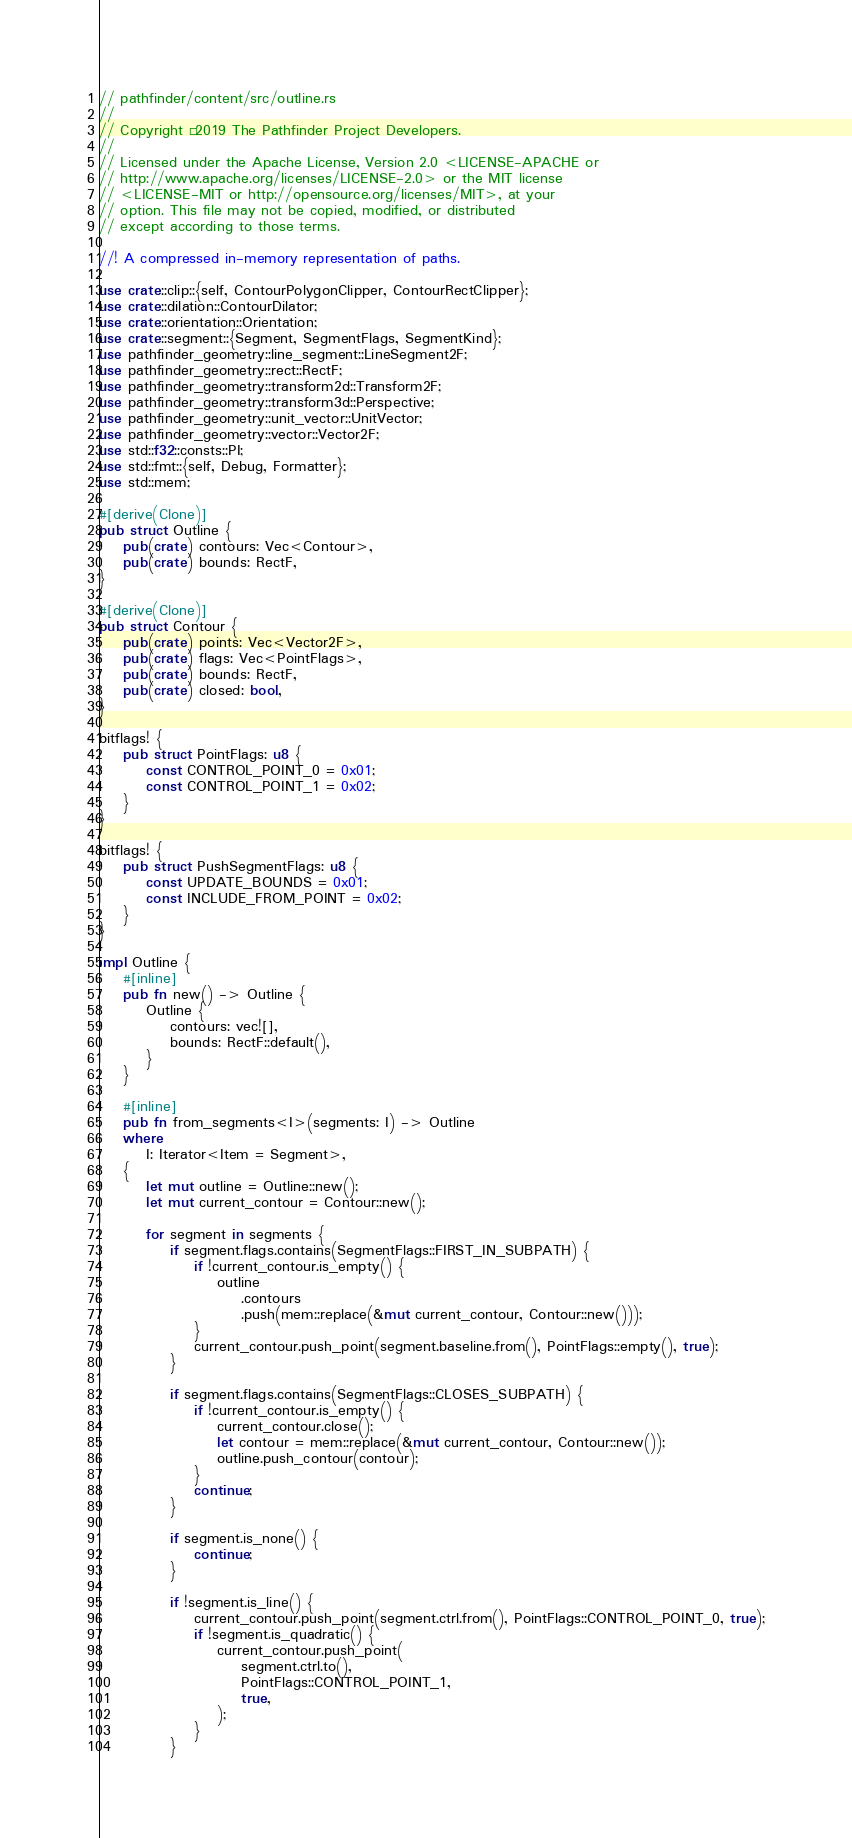Convert code to text. <code><loc_0><loc_0><loc_500><loc_500><_Rust_>// pathfinder/content/src/outline.rs
//
// Copyright © 2019 The Pathfinder Project Developers.
//
// Licensed under the Apache License, Version 2.0 <LICENSE-APACHE or
// http://www.apache.org/licenses/LICENSE-2.0> or the MIT license
// <LICENSE-MIT or http://opensource.org/licenses/MIT>, at your
// option. This file may not be copied, modified, or distributed
// except according to those terms.

//! A compressed in-memory representation of paths.

use crate::clip::{self, ContourPolygonClipper, ContourRectClipper};
use crate::dilation::ContourDilator;
use crate::orientation::Orientation;
use crate::segment::{Segment, SegmentFlags, SegmentKind};
use pathfinder_geometry::line_segment::LineSegment2F;
use pathfinder_geometry::rect::RectF;
use pathfinder_geometry::transform2d::Transform2F;
use pathfinder_geometry::transform3d::Perspective;
use pathfinder_geometry::unit_vector::UnitVector;
use pathfinder_geometry::vector::Vector2F;
use std::f32::consts::PI;
use std::fmt::{self, Debug, Formatter};
use std::mem;

#[derive(Clone)]
pub struct Outline {
    pub(crate) contours: Vec<Contour>,
    pub(crate) bounds: RectF,
}

#[derive(Clone)]
pub struct Contour {
    pub(crate) points: Vec<Vector2F>,
    pub(crate) flags: Vec<PointFlags>,
    pub(crate) bounds: RectF,
    pub(crate) closed: bool,
}

bitflags! {
    pub struct PointFlags: u8 {
        const CONTROL_POINT_0 = 0x01;
        const CONTROL_POINT_1 = 0x02;
    }
}

bitflags! {
    pub struct PushSegmentFlags: u8 {
        const UPDATE_BOUNDS = 0x01;
        const INCLUDE_FROM_POINT = 0x02;
    }
}

impl Outline {
    #[inline]
    pub fn new() -> Outline {
        Outline {
            contours: vec![],
            bounds: RectF::default(),
        }
    }

    #[inline]
    pub fn from_segments<I>(segments: I) -> Outline
    where
        I: Iterator<Item = Segment>,
    {
        let mut outline = Outline::new();
        let mut current_contour = Contour::new();

        for segment in segments {
            if segment.flags.contains(SegmentFlags::FIRST_IN_SUBPATH) {
                if !current_contour.is_empty() {
                    outline
                        .contours
                        .push(mem::replace(&mut current_contour, Contour::new()));
                }
                current_contour.push_point(segment.baseline.from(), PointFlags::empty(), true);
            }

            if segment.flags.contains(SegmentFlags::CLOSES_SUBPATH) {
                if !current_contour.is_empty() {
                    current_contour.close();
                    let contour = mem::replace(&mut current_contour, Contour::new());
                    outline.push_contour(contour);
                }
                continue;
            }

            if segment.is_none() {
                continue;
            }

            if !segment.is_line() {
                current_contour.push_point(segment.ctrl.from(), PointFlags::CONTROL_POINT_0, true);
                if !segment.is_quadratic() {
                    current_contour.push_point(
                        segment.ctrl.to(),
                        PointFlags::CONTROL_POINT_1,
                        true,
                    );
                }
            }
</code> 